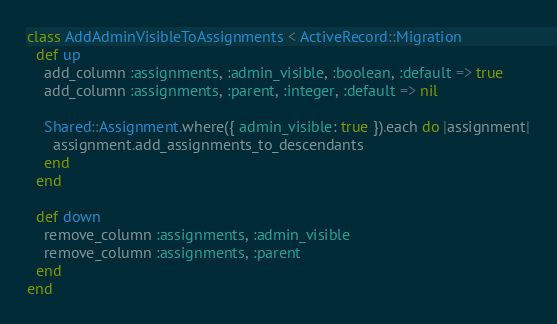<code> <loc_0><loc_0><loc_500><loc_500><_Ruby_>class AddAdminVisibleToAssignments < ActiveRecord::Migration
  def up
    add_column :assignments, :admin_visible, :boolean, :default => true
    add_column :assignments, :parent, :integer, :default => nil

    Shared::Assignment.where({ admin_visible: true }).each do |assignment|
      assignment.add_assignments_to_descendants
    end
  end

  def down
    remove_column :assignments, :admin_visible
    remove_column :assignments, :parent
  end
end
</code> 